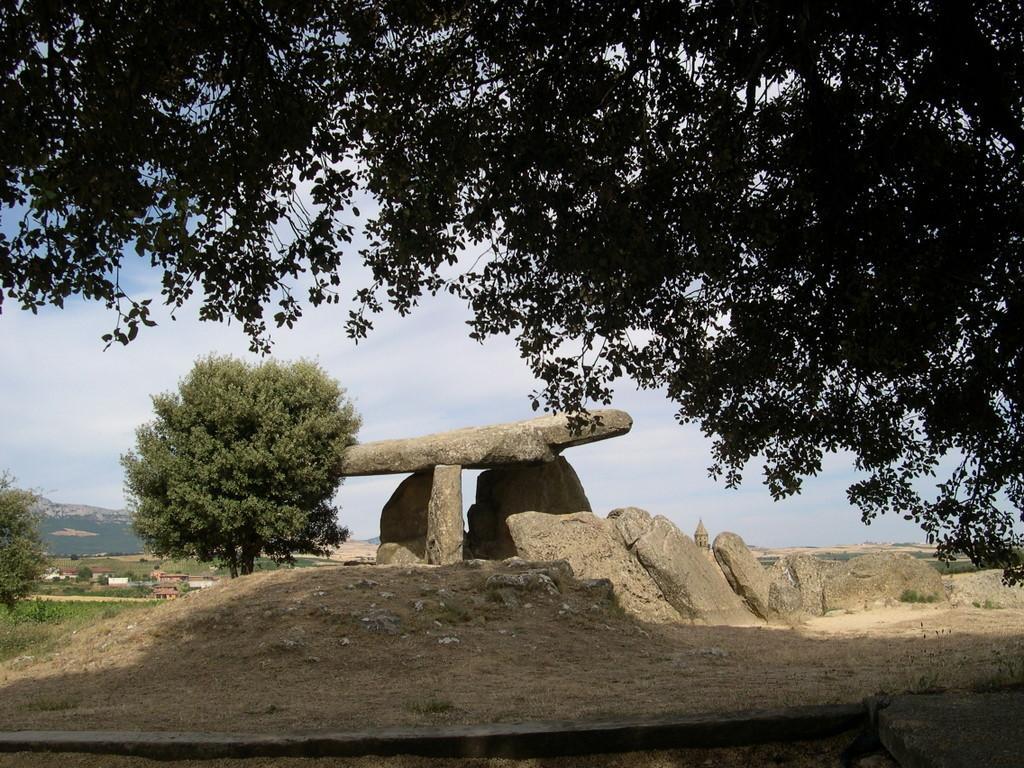Please provide a concise description of this image. In this image at the bottom, there are stones, trees, grass, hills and land. At the top there are trees, sky and clouds. 